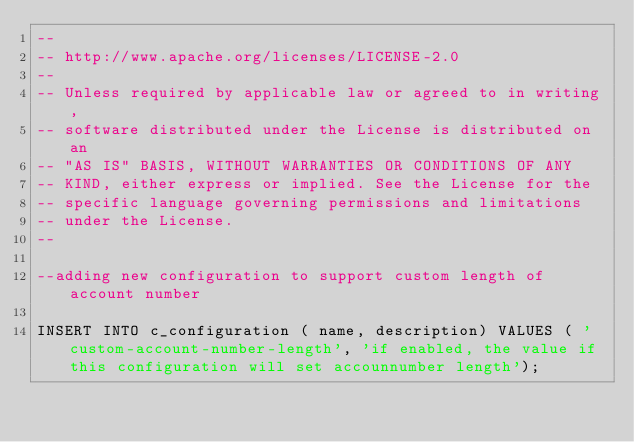Convert code to text. <code><loc_0><loc_0><loc_500><loc_500><_SQL_>--
-- http://www.apache.org/licenses/LICENSE-2.0
--
-- Unless required by applicable law or agreed to in writing,
-- software distributed under the License is distributed on an
-- "AS IS" BASIS, WITHOUT WARRANTIES OR CONDITIONS OF ANY
-- KIND, either express or implied. See the License for the
-- specific language governing permissions and limitations
-- under the License.
--

--adding new configuration to support custom length of account number

INSERT INTO c_configuration ( name, description) VALUES ( 'custom-account-number-length', 'if enabled, the value if this configuration will set accounnumber length');</code> 